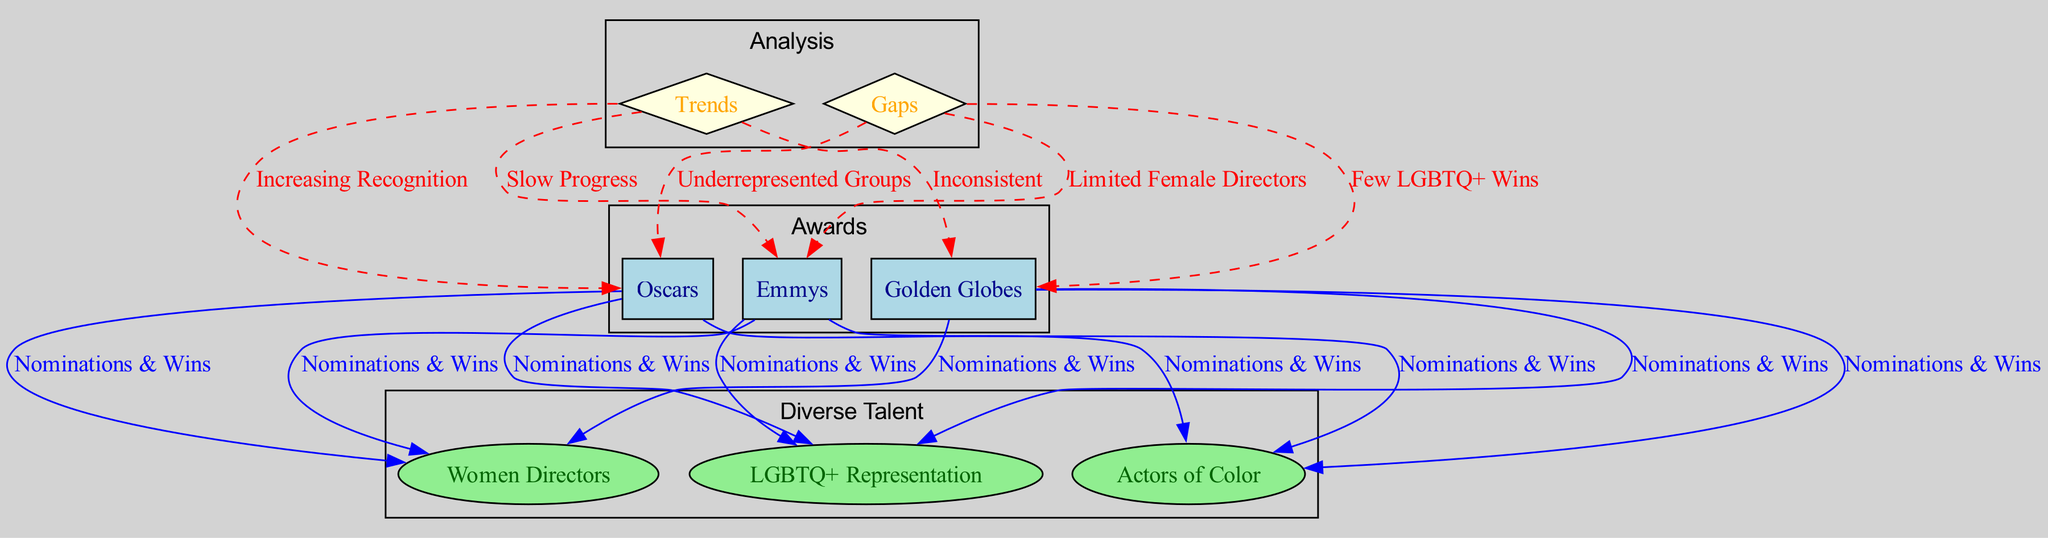What three major awards are represented in the diagram? The diagram shows three major awards: Oscars, Emmys, and Golden Globes, which are all listed as nodes labeled accordingly.
Answer: Oscars, Emmys, Golden Globes Which group is highlighted as having nominations and wins in the Emmys? The diagram connects the Emmys node to the Actors of Color, Women Directors, and LGBTQ+ Representation nodes, indicating they all have nominations and wins under the Emmys.
Answer: Actors of Color, Women Directors, LGBTQ+ Representation Which trend is associated with the Oscars according to the diagram? The edge connected from the Trends node to the Oscars indicates the trend labeled "Increasing Recognition," reflecting a positive acknowledgment of diverse talent at the Oscars.
Answer: Increasing Recognition What are the identified gaps for the Golden Globes? The diagram highlights a direct connection from the Gaps node to the Golden Globes with the label "Few LGBTQ+ Wins," indicating this is a significant gap in recognition.
Answer: Few LGBTQ+ Wins How many edges connect the Oscars to diverse talent categories? There are three edges connecting the Oscars to the diverse talent categories: Actors of Color, Women Directors, and LGBTQ+ Representation, measuring the direct relationships between the Oscars and diverse contributions.
Answer: 3 Which category shows a trend of slow progress? The diagram connects the Trends node to the Emmys with the label "Slow Progress," indicating the trend for that specific award category.
Answer: Slow Progress What node represents the analysis of representation in the diagram? The diagram indicates the analysis of the overall representation through the Trends and Gaps nodes, which summarize both positive and negative aspects regarding diverse talent in media.
Answer: Trends, Gaps Which award displays the trend of inconsistency? The edge from the Trends node to the Golden Globes is labeled "Inconsistent," highlighting the varying levels of recognition for diverse talent in this particular award.
Answer: Inconsistent What two groups are specified as underrepresented in the Oscars? The diagram connects the Underrepresented Groups gap to the Oscars and includes the related label indicating that both Actors of Color and Women Directors are cited as underrepresented.
Answer: Actors of Color, Women Directors 